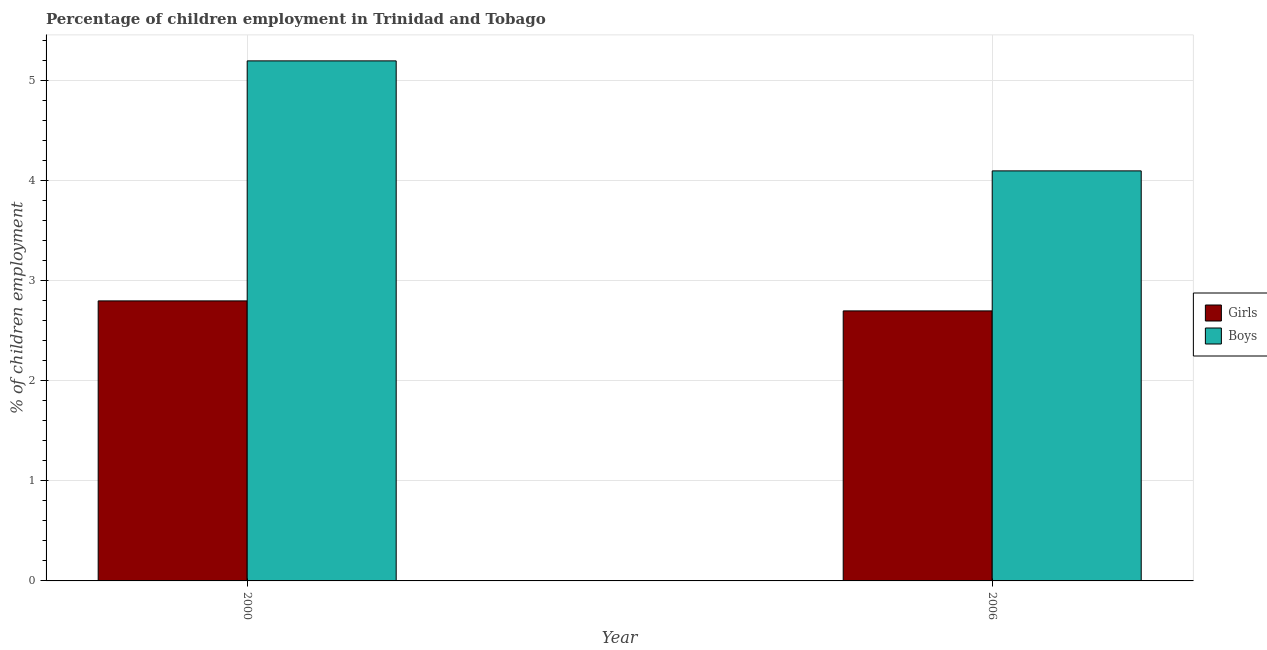How many different coloured bars are there?
Ensure brevity in your answer.  2. How many groups of bars are there?
Offer a very short reply. 2. Are the number of bars on each tick of the X-axis equal?
Ensure brevity in your answer.  Yes. How many bars are there on the 2nd tick from the left?
Give a very brief answer. 2. What is the label of the 2nd group of bars from the left?
Provide a short and direct response. 2006. In how many cases, is the number of bars for a given year not equal to the number of legend labels?
Your answer should be very brief. 0. What is the percentage of employed girls in 2000?
Your answer should be very brief. 2.8. Across all years, what is the maximum percentage of employed boys?
Offer a very short reply. 5.2. Across all years, what is the minimum percentage of employed boys?
Offer a very short reply. 4.1. In which year was the percentage of employed boys maximum?
Your answer should be very brief. 2000. What is the difference between the percentage of employed girls in 2000 and that in 2006?
Your answer should be very brief. 0.1. What is the difference between the percentage of employed boys in 2006 and the percentage of employed girls in 2000?
Your answer should be very brief. -1.1. What is the average percentage of employed girls per year?
Provide a succinct answer. 2.75. In the year 2006, what is the difference between the percentage of employed boys and percentage of employed girls?
Your answer should be very brief. 0. What is the ratio of the percentage of employed girls in 2000 to that in 2006?
Give a very brief answer. 1.04. Is the percentage of employed boys in 2000 less than that in 2006?
Ensure brevity in your answer.  No. What does the 2nd bar from the left in 2006 represents?
Your response must be concise. Boys. What does the 2nd bar from the right in 2006 represents?
Make the answer very short. Girls. Are the values on the major ticks of Y-axis written in scientific E-notation?
Your answer should be very brief. No. Does the graph contain any zero values?
Provide a succinct answer. No. Does the graph contain grids?
Make the answer very short. Yes. What is the title of the graph?
Provide a short and direct response. Percentage of children employment in Trinidad and Tobago. Does "Electricity and heat production" appear as one of the legend labels in the graph?
Your response must be concise. No. What is the label or title of the X-axis?
Keep it short and to the point. Year. What is the label or title of the Y-axis?
Keep it short and to the point. % of children employment. What is the % of children employment in Boys in 2000?
Your response must be concise. 5.2. Across all years, what is the maximum % of children employment in Girls?
Your answer should be very brief. 2.8. Across all years, what is the minimum % of children employment of Girls?
Your answer should be compact. 2.7. Across all years, what is the minimum % of children employment of Boys?
Offer a terse response. 4.1. What is the total % of children employment in Girls in the graph?
Your response must be concise. 5.5. What is the difference between the % of children employment in Boys in 2000 and that in 2006?
Give a very brief answer. 1.1. What is the difference between the % of children employment in Girls in 2000 and the % of children employment in Boys in 2006?
Keep it short and to the point. -1.3. What is the average % of children employment in Girls per year?
Your response must be concise. 2.75. What is the average % of children employment in Boys per year?
Your answer should be compact. 4.65. In the year 2000, what is the difference between the % of children employment of Girls and % of children employment of Boys?
Give a very brief answer. -2.4. What is the ratio of the % of children employment of Boys in 2000 to that in 2006?
Make the answer very short. 1.27. What is the difference between the highest and the lowest % of children employment in Girls?
Your answer should be very brief. 0.1. 